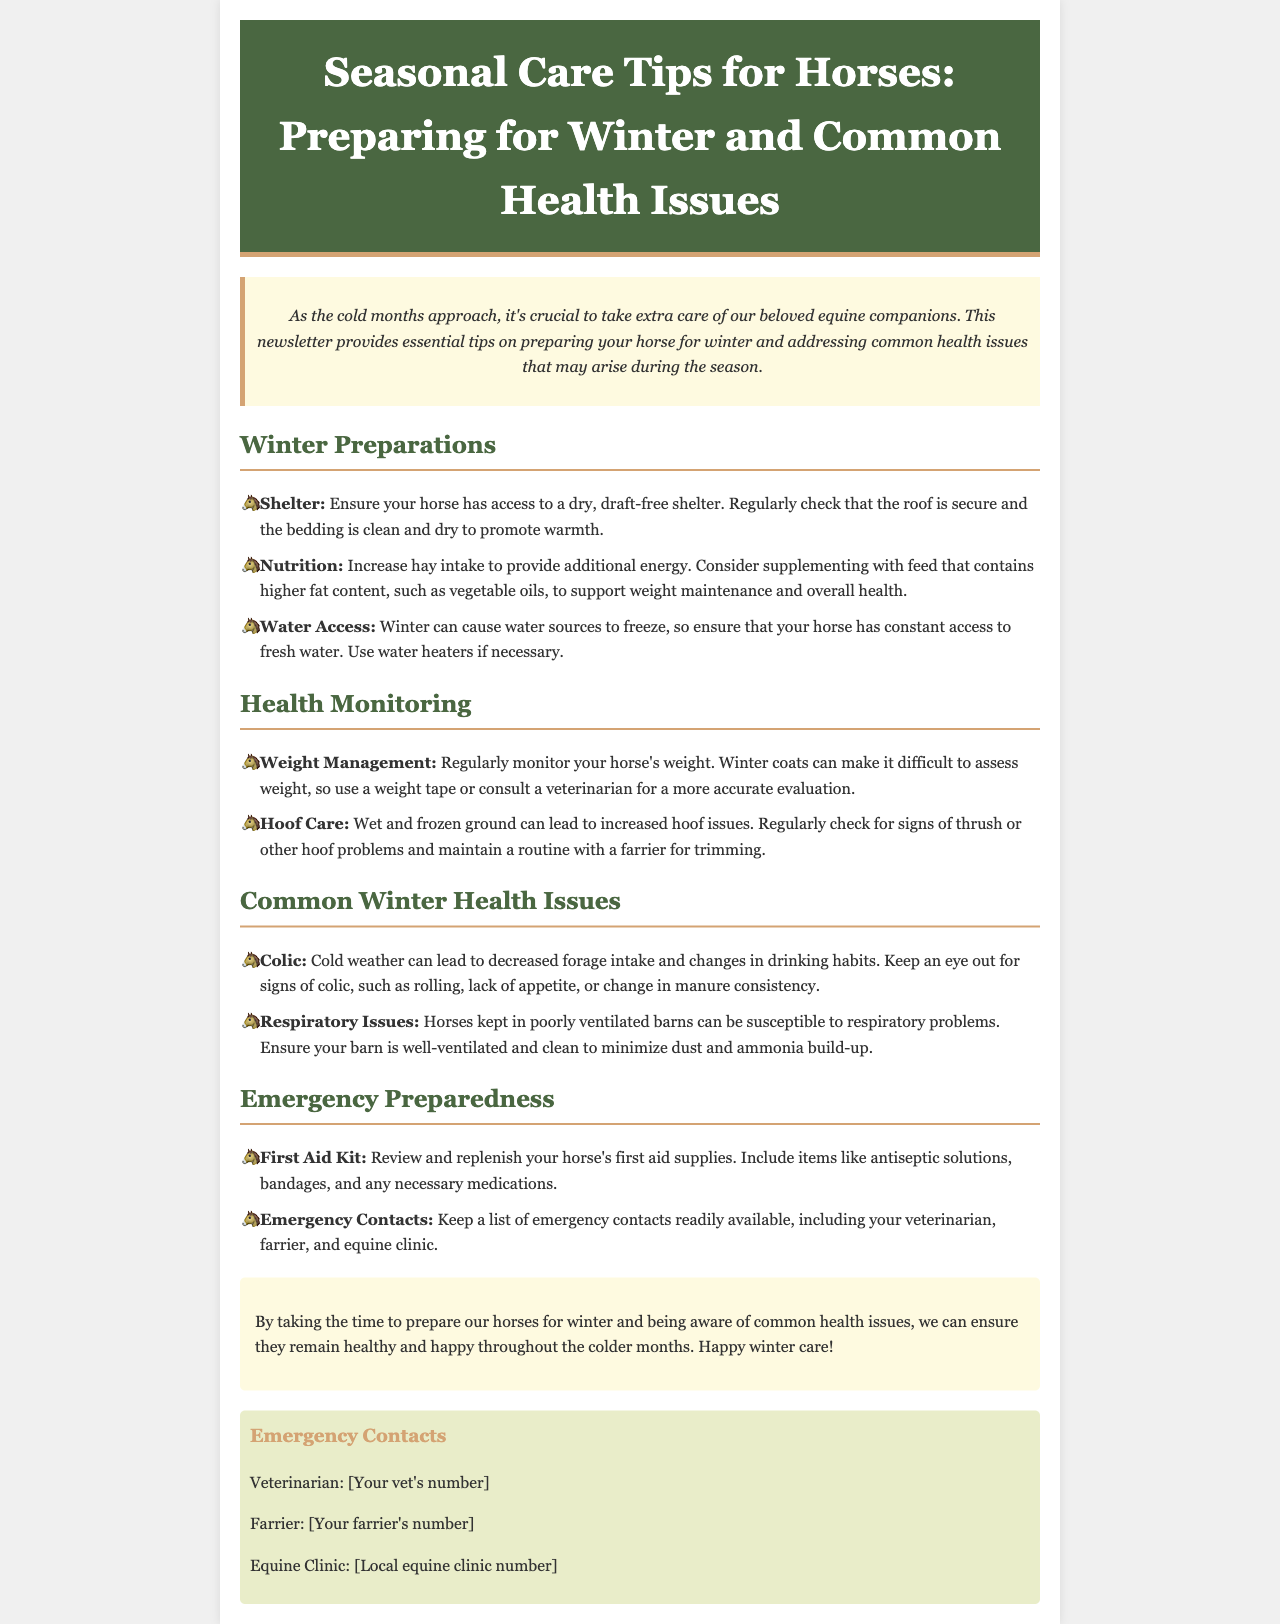What should horses have access to during winter? The document states that horses should have access to a dry, draft-free shelter to promote warmth.
Answer: Shelter How can you support your horse's weight maintenance in winter? It suggests supplementing with feed that contains higher fat content, such as vegetable oils.
Answer: Higher fat content feed What common health issue may arise due to cold weather? Cold weather can lead to decreased forage intake and changes in drinking habits, which can cause colic.
Answer: Colic What are two key aspects of Health Monitoring mentioned? The key aspects are weight management and hoof care.
Answer: Weight management and hoof care What should be included in a horse’s first aid kit? The first aid kit should include items like antiseptic solutions, bandages, and any necessary medications.
Answer: Antiseptic solutions, bandages, medications How should barn ventilation be handled in winter? The document recommends ensuring that the barn is well-ventilated and clean to minimize dust and ammonia build-up.
Answer: Well-ventilated and clean What is a sign of colic to look out for in horses? Signs of colic include rolling, lack of appetite, or change in manure consistency.
Answer: Rolling, lack of appetite, change in manure consistency What should you do regarding water access in winter? It's important to ensure that your horse has constant access to fresh water and to use water heaters if necessary.
Answer: Use water heaters Which emergency contacts are recommended to be kept available? The recommended emergency contacts include your veterinarian, farrier, and equine clinic.
Answer: Veterinarian, farrier, equine clinic 